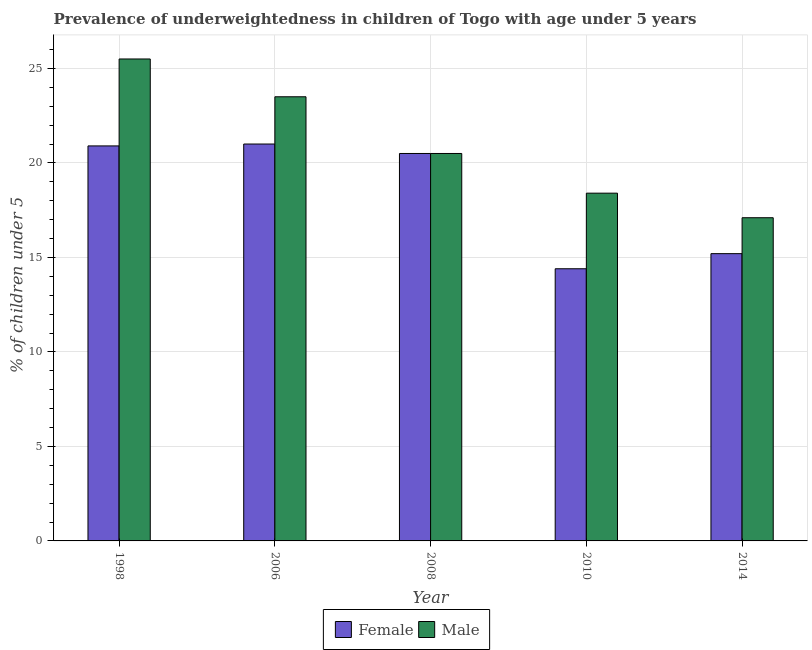Are the number of bars per tick equal to the number of legend labels?
Give a very brief answer. Yes. Are the number of bars on each tick of the X-axis equal?
Keep it short and to the point. Yes. How many bars are there on the 4th tick from the left?
Your response must be concise. 2. How many bars are there on the 1st tick from the right?
Your answer should be compact. 2. What is the label of the 5th group of bars from the left?
Provide a succinct answer. 2014. In how many cases, is the number of bars for a given year not equal to the number of legend labels?
Make the answer very short. 0. What is the percentage of underweighted female children in 2010?
Offer a terse response. 14.4. Across all years, what is the minimum percentage of underweighted male children?
Your answer should be very brief. 17.1. What is the total percentage of underweighted male children in the graph?
Provide a short and direct response. 105. What is the difference between the percentage of underweighted male children in 2010 and that in 2014?
Provide a succinct answer. 1.3. What is the difference between the percentage of underweighted female children in 2008 and the percentage of underweighted male children in 1998?
Your answer should be compact. -0.4. What is the average percentage of underweighted male children per year?
Keep it short and to the point. 21. In the year 2014, what is the difference between the percentage of underweighted male children and percentage of underweighted female children?
Your answer should be compact. 0. What is the ratio of the percentage of underweighted female children in 2006 to that in 2008?
Make the answer very short. 1.02. Is the percentage of underweighted female children in 2008 less than that in 2010?
Ensure brevity in your answer.  No. What is the difference between the highest and the second highest percentage of underweighted male children?
Offer a terse response. 2. What is the difference between the highest and the lowest percentage of underweighted female children?
Provide a short and direct response. 6.6. Is the sum of the percentage of underweighted female children in 2008 and 2010 greater than the maximum percentage of underweighted male children across all years?
Offer a very short reply. Yes. How many bars are there?
Provide a succinct answer. 10. Are all the bars in the graph horizontal?
Provide a succinct answer. No. How many years are there in the graph?
Your answer should be compact. 5. What is the difference between two consecutive major ticks on the Y-axis?
Give a very brief answer. 5. Does the graph contain grids?
Your response must be concise. Yes. Where does the legend appear in the graph?
Your answer should be compact. Bottom center. What is the title of the graph?
Ensure brevity in your answer.  Prevalence of underweightedness in children of Togo with age under 5 years. What is the label or title of the Y-axis?
Make the answer very short.  % of children under 5. What is the  % of children under 5 in Female in 1998?
Your answer should be compact. 20.9. What is the  % of children under 5 of Male in 1998?
Make the answer very short. 25.5. What is the  % of children under 5 of Female in 2006?
Keep it short and to the point. 21. What is the  % of children under 5 in Female in 2008?
Offer a very short reply. 20.5. What is the  % of children under 5 of Male in 2008?
Your response must be concise. 20.5. What is the  % of children under 5 of Female in 2010?
Give a very brief answer. 14.4. What is the  % of children under 5 of Male in 2010?
Provide a short and direct response. 18.4. What is the  % of children under 5 in Female in 2014?
Keep it short and to the point. 15.2. What is the  % of children under 5 of Male in 2014?
Give a very brief answer. 17.1. Across all years, what is the maximum  % of children under 5 of Male?
Provide a succinct answer. 25.5. Across all years, what is the minimum  % of children under 5 of Female?
Provide a succinct answer. 14.4. Across all years, what is the minimum  % of children under 5 in Male?
Give a very brief answer. 17.1. What is the total  % of children under 5 of Female in the graph?
Give a very brief answer. 92. What is the total  % of children under 5 in Male in the graph?
Your response must be concise. 105. What is the difference between the  % of children under 5 of Male in 1998 and that in 2006?
Provide a succinct answer. 2. What is the difference between the  % of children under 5 of Male in 1998 and that in 2010?
Give a very brief answer. 7.1. What is the difference between the  % of children under 5 in Female in 1998 and that in 2014?
Provide a succinct answer. 5.7. What is the difference between the  % of children under 5 in Male in 1998 and that in 2014?
Your answer should be very brief. 8.4. What is the difference between the  % of children under 5 in Female in 2006 and that in 2010?
Ensure brevity in your answer.  6.6. What is the difference between the  % of children under 5 of Male in 2006 and that in 2010?
Your response must be concise. 5.1. What is the difference between the  % of children under 5 of Female in 2006 and that in 2014?
Keep it short and to the point. 5.8. What is the difference between the  % of children under 5 in Male in 2006 and that in 2014?
Offer a very short reply. 6.4. What is the difference between the  % of children under 5 of Female in 2008 and that in 2010?
Offer a terse response. 6.1. What is the difference between the  % of children under 5 in Male in 2008 and that in 2010?
Your answer should be compact. 2.1. What is the difference between the  % of children under 5 of Female in 2008 and that in 2014?
Offer a terse response. 5.3. What is the difference between the  % of children under 5 in Male in 2008 and that in 2014?
Provide a short and direct response. 3.4. What is the difference between the  % of children under 5 in Female in 1998 and the  % of children under 5 in Male in 2006?
Ensure brevity in your answer.  -2.6. What is the difference between the  % of children under 5 in Female in 1998 and the  % of children under 5 in Male in 2010?
Your answer should be very brief. 2.5. What is the difference between the  % of children under 5 of Female in 2006 and the  % of children under 5 of Male in 2010?
Offer a very short reply. 2.6. What is the difference between the  % of children under 5 of Female in 2008 and the  % of children under 5 of Male in 2010?
Your answer should be compact. 2.1. What is the average  % of children under 5 in Female per year?
Give a very brief answer. 18.4. What is the ratio of the  % of children under 5 in Female in 1998 to that in 2006?
Offer a terse response. 1. What is the ratio of the  % of children under 5 in Male in 1998 to that in 2006?
Keep it short and to the point. 1.09. What is the ratio of the  % of children under 5 of Female in 1998 to that in 2008?
Offer a very short reply. 1.02. What is the ratio of the  % of children under 5 in Male in 1998 to that in 2008?
Your response must be concise. 1.24. What is the ratio of the  % of children under 5 in Female in 1998 to that in 2010?
Your answer should be very brief. 1.45. What is the ratio of the  % of children under 5 in Male in 1998 to that in 2010?
Your response must be concise. 1.39. What is the ratio of the  % of children under 5 in Female in 1998 to that in 2014?
Your response must be concise. 1.38. What is the ratio of the  % of children under 5 of Male in 1998 to that in 2014?
Ensure brevity in your answer.  1.49. What is the ratio of the  % of children under 5 of Female in 2006 to that in 2008?
Keep it short and to the point. 1.02. What is the ratio of the  % of children under 5 in Male in 2006 to that in 2008?
Your answer should be compact. 1.15. What is the ratio of the  % of children under 5 in Female in 2006 to that in 2010?
Ensure brevity in your answer.  1.46. What is the ratio of the  % of children under 5 in Male in 2006 to that in 2010?
Ensure brevity in your answer.  1.28. What is the ratio of the  % of children under 5 in Female in 2006 to that in 2014?
Your answer should be very brief. 1.38. What is the ratio of the  % of children under 5 of Male in 2006 to that in 2014?
Provide a short and direct response. 1.37. What is the ratio of the  % of children under 5 in Female in 2008 to that in 2010?
Offer a very short reply. 1.42. What is the ratio of the  % of children under 5 in Male in 2008 to that in 2010?
Make the answer very short. 1.11. What is the ratio of the  % of children under 5 of Female in 2008 to that in 2014?
Offer a terse response. 1.35. What is the ratio of the  % of children under 5 in Male in 2008 to that in 2014?
Your answer should be compact. 1.2. What is the ratio of the  % of children under 5 in Male in 2010 to that in 2014?
Offer a very short reply. 1.08. What is the difference between the highest and the second highest  % of children under 5 of Female?
Your answer should be compact. 0.1. What is the difference between the highest and the second highest  % of children under 5 of Male?
Make the answer very short. 2. 